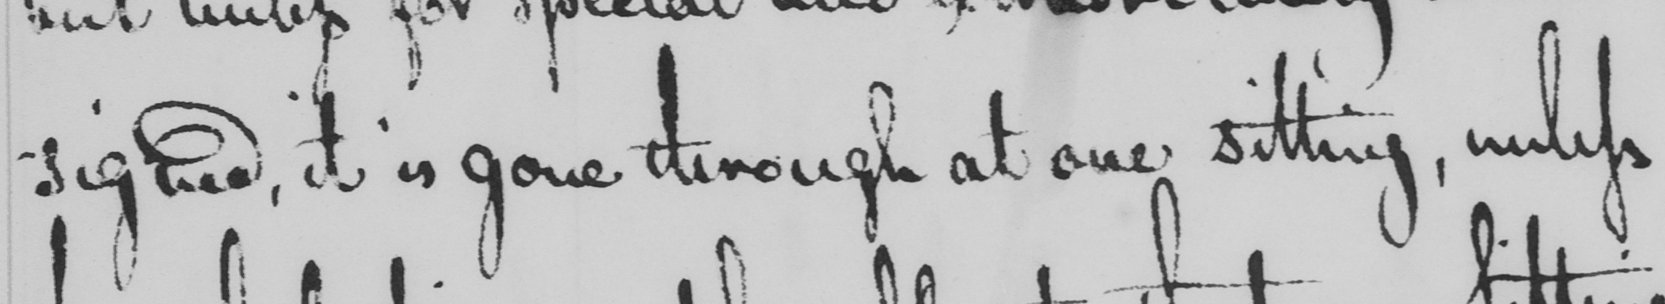Please provide the text content of this handwritten line. -signed, it is gone through at one sitting, unless 